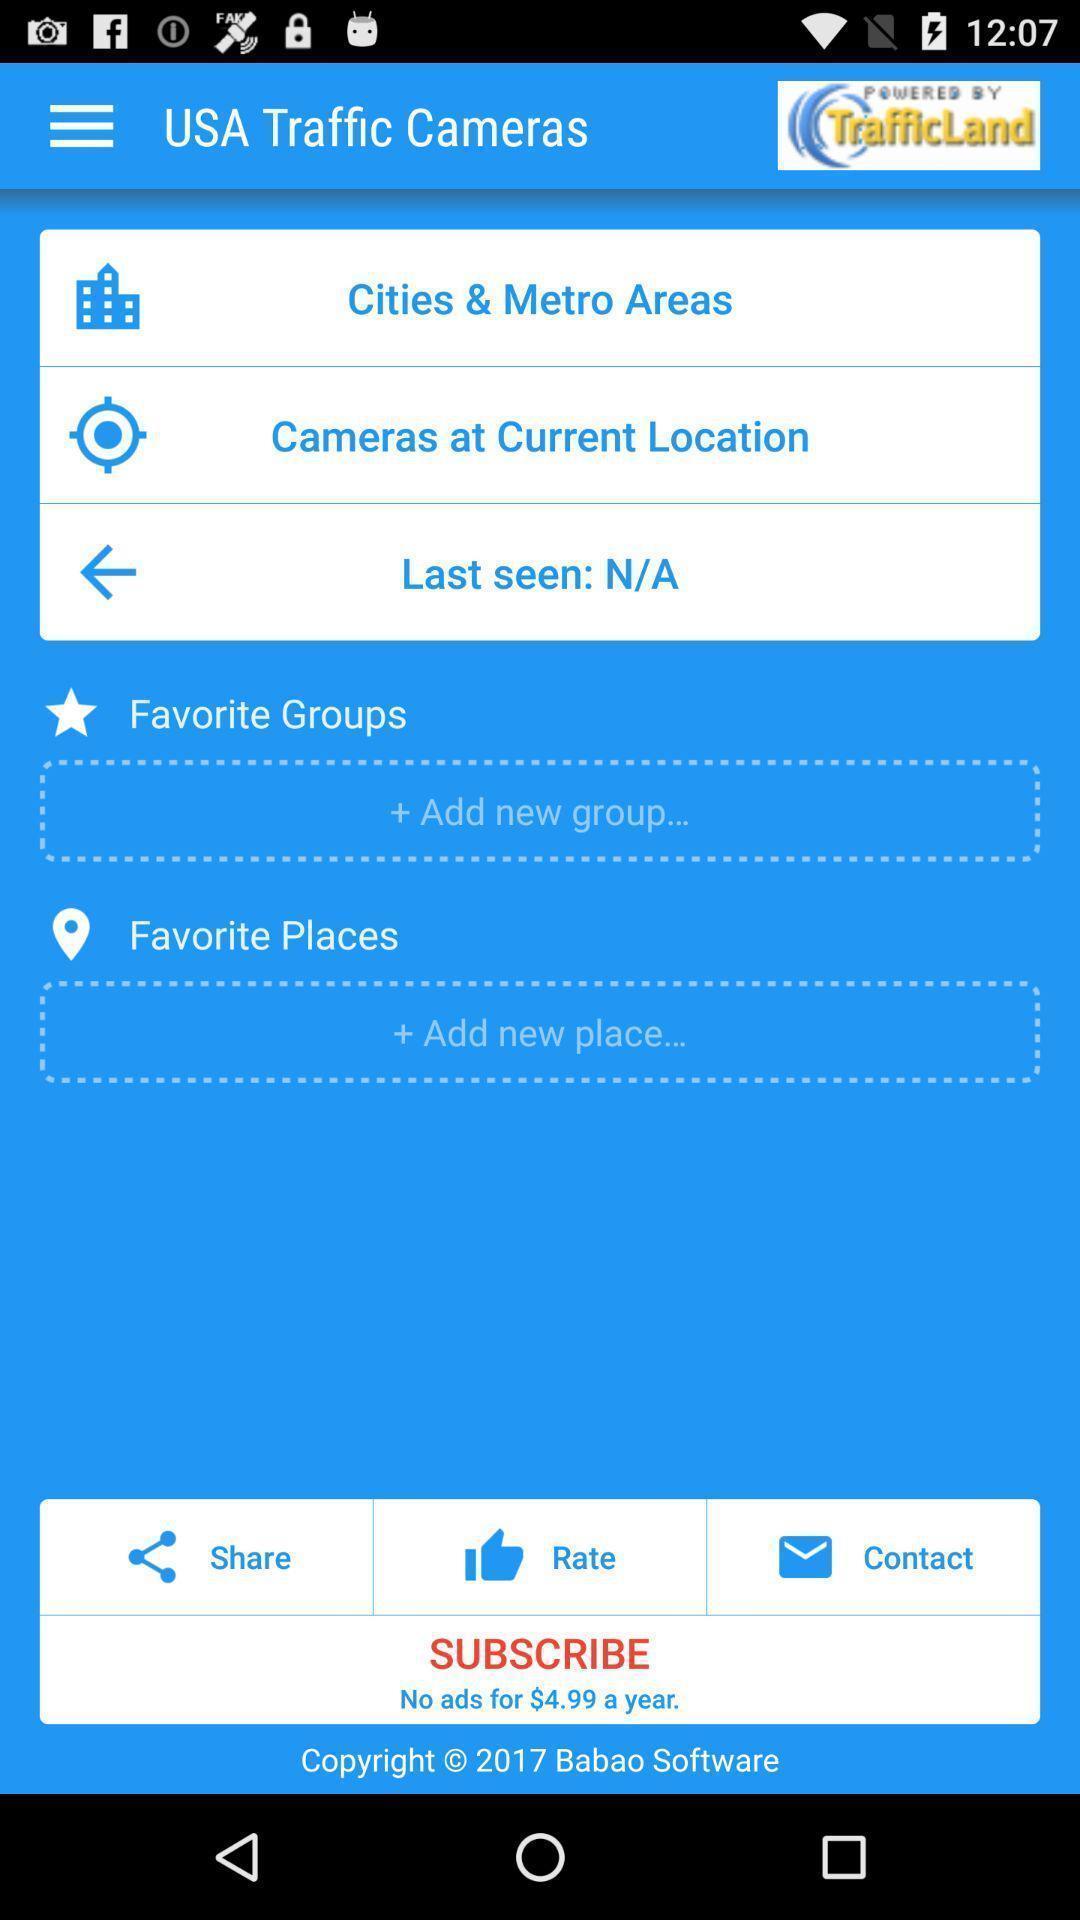What is the overall content of this screenshot? Usa traffic cameras in the traffic land. 